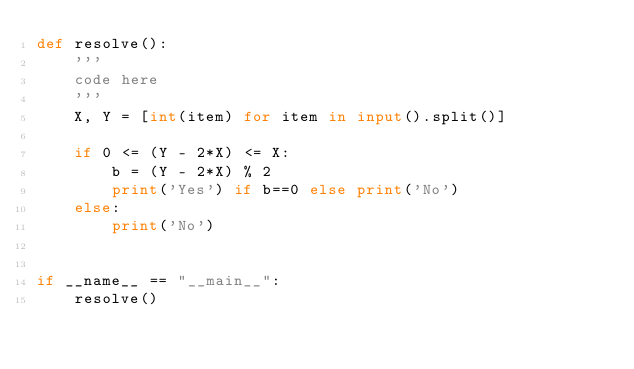<code> <loc_0><loc_0><loc_500><loc_500><_Python_>def resolve():
    '''
    code here
    '''
    X, Y = [int(item) for item in input().split()]

    if 0 <= (Y - 2*X) <= X:
        b = (Y - 2*X) % 2
        print('Yes') if b==0 else print('No')
    else:
        print('No')


if __name__ == "__main__":
    resolve()
</code> 